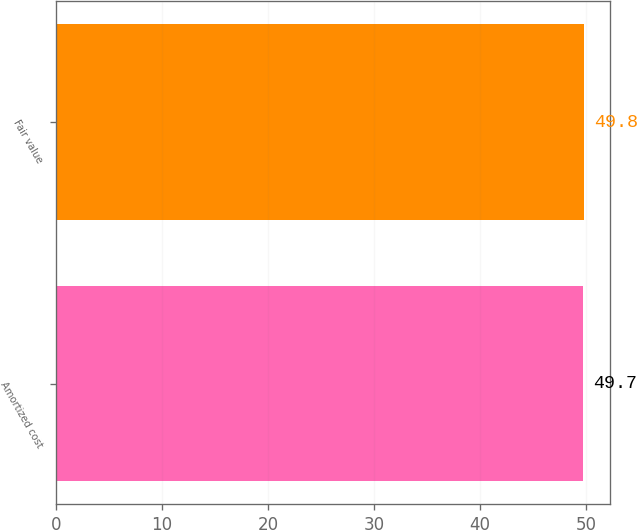<chart> <loc_0><loc_0><loc_500><loc_500><bar_chart><fcel>Amortized cost<fcel>Fair value<nl><fcel>49.7<fcel>49.8<nl></chart> 